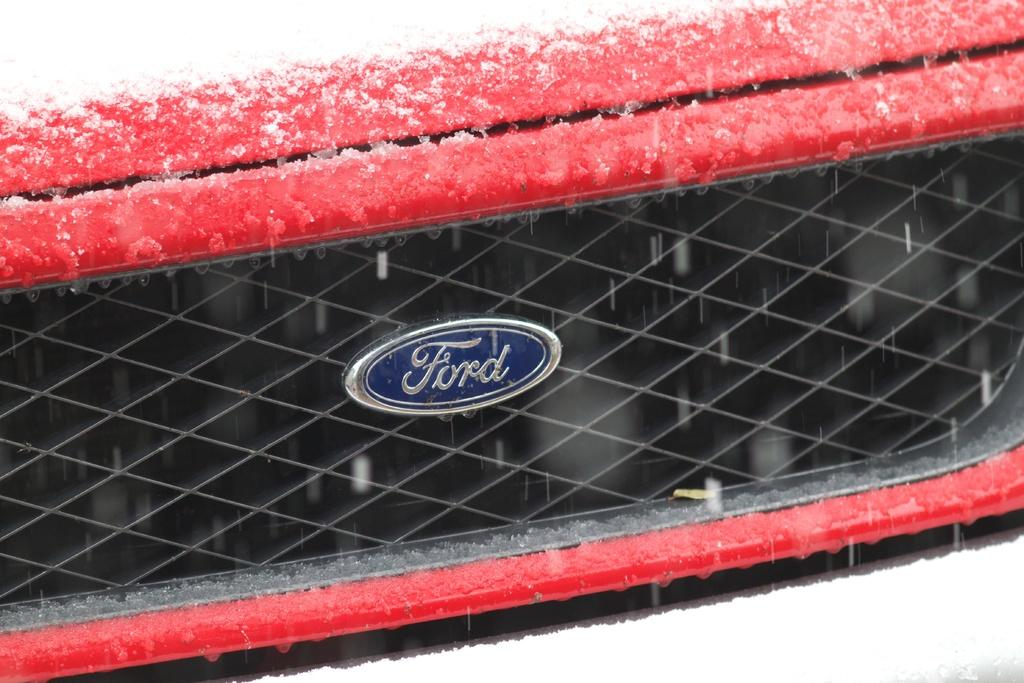What type of vehicle part is visible in the image? There is a part of a vehicle in the image, which appears to be a bumper. What is covering the bumper in the image? There is snow on the bumper in the image. Is there any text visible in the image? Yes, there is some text visible in the image. Can you see any feathers falling from the sky in the image? There are no feathers visible in the image. Is the vehicle part being attacked by any animals in the image? There is no indication of an attack or any animals present in the image. 